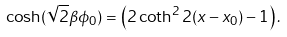<formula> <loc_0><loc_0><loc_500><loc_500>\cosh ( \sqrt { 2 } \beta \phi _ { 0 } ) = \left ( 2 \coth ^ { 2 } 2 ( x - x _ { 0 } ) - 1 \right ) .</formula> 